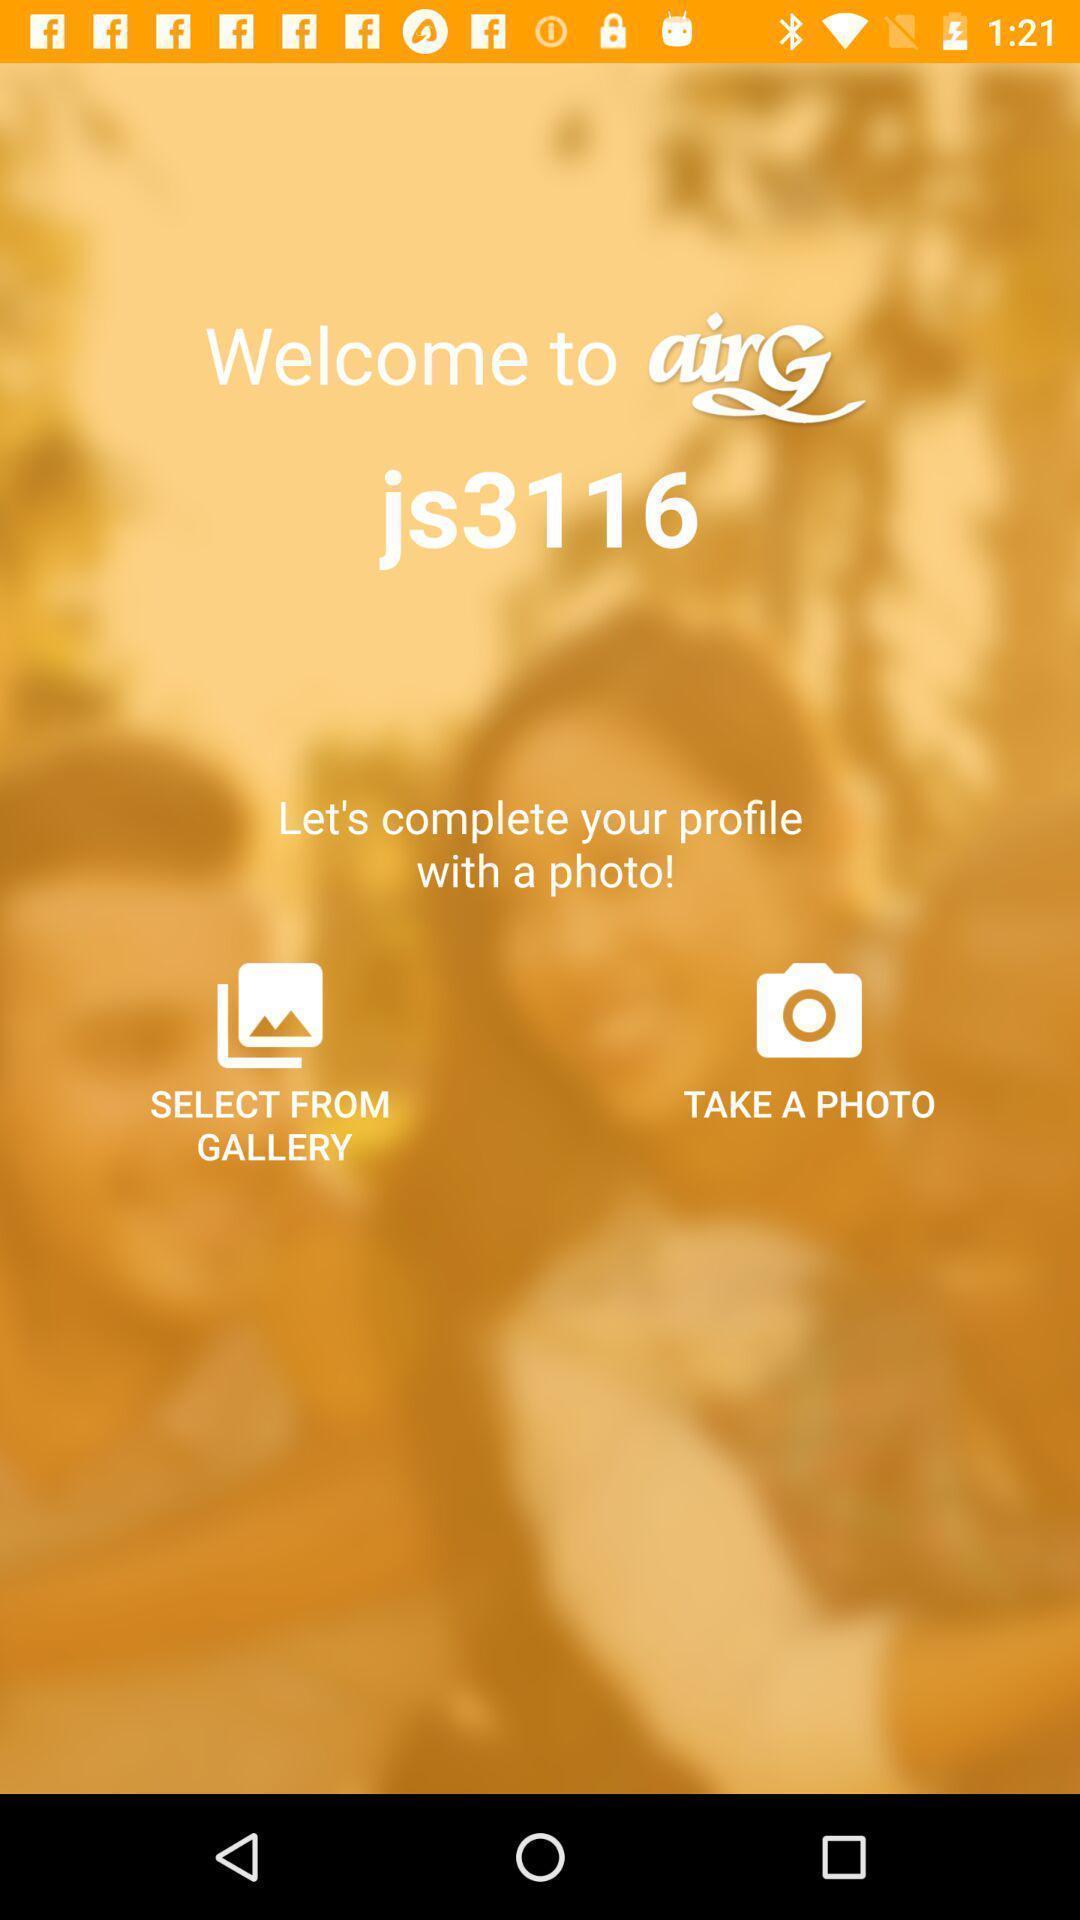Summarize the information in this screenshot. Welcome page of social application. 